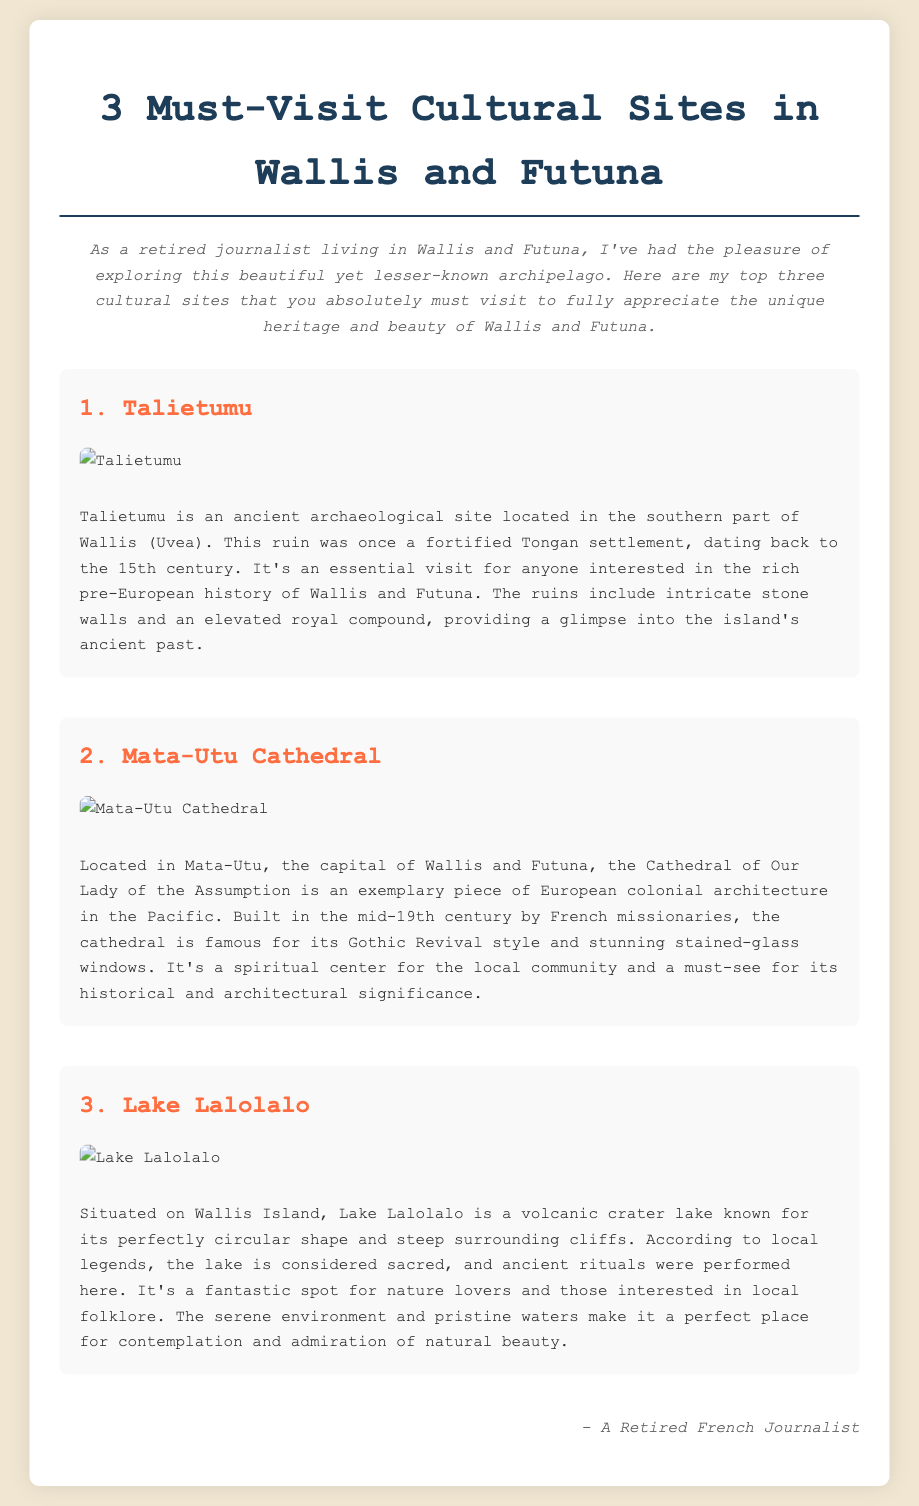What is the first must-visit cultural site? The first site listed in the infographic is Talietumu.
Answer: Talietumu What century does the Talietumu site date back to? The document states that Talietumu dates back to the 15th century.
Answer: 15th century What is the architectural style of the Mata-Utu Cathedral? The Mata-Utu Cathedral is famous for its Gothic Revival style according to the document.
Answer: Gothic Revival Where is Lake Lalolalo located? According to the document, Lake Lalolalo is situated on Wallis Island.
Answer: Wallis Island What type of natural feature is Lake Lalolalo described as? The document describes Lake Lalolalo as a volcanic crater lake.
Answer: volcanic crater lake Which cultural site serves as a spiritual center for the local community? The infographic mentions that the Mata-Utu Cathedral serves as a spiritual center for the local community.
Answer: Mata-Utu Cathedral How many cultural sites are recommended in the document? The document lists three must-visit cultural sites.
Answer: three What type of document structure is used in this infographic? The document follows a list structure, highlighting different cultural sites with descriptions.
Answer: list structure 